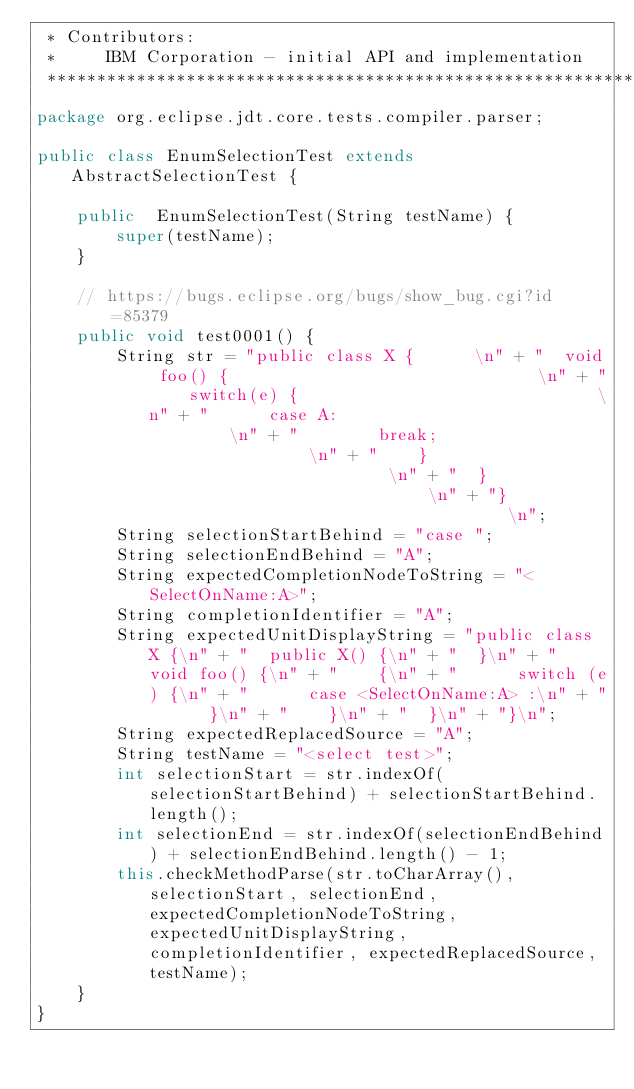<code> <loc_0><loc_0><loc_500><loc_500><_Java_> * Contributors:
 *     IBM Corporation - initial API and implementation
 *******************************************************************************/
package org.eclipse.jdt.core.tests.compiler.parser;

public class EnumSelectionTest extends AbstractSelectionTest {

    public  EnumSelectionTest(String testName) {
        super(testName);
    }

    // https://bugs.eclipse.org/bugs/show_bug.cgi?id=85379
    public void test0001() {
        String str = "public class X {		\n" + "  void foo() {								\n" + "    switch(e) {  							\n" + "      case A:								\n" + "        break;								\n" + "    }        								\n" + "  }        								\n" + "}											\n";
        String selectionStartBehind = "case ";
        String selectionEndBehind = "A";
        String expectedCompletionNodeToString = "<SelectOnName:A>";
        String completionIdentifier = "A";
        String expectedUnitDisplayString = "public class X {\n" + "  public X() {\n" + "  }\n" + "  void foo() {\n" + "    {\n" + "      switch (e) {\n" + "      case <SelectOnName:A> :\n" + "      }\n" + "    }\n" + "  }\n" + "}\n";
        String expectedReplacedSource = "A";
        String testName = "<select test>";
        int selectionStart = str.indexOf(selectionStartBehind) + selectionStartBehind.length();
        int selectionEnd = str.indexOf(selectionEndBehind) + selectionEndBehind.length() - 1;
        this.checkMethodParse(str.toCharArray(), selectionStart, selectionEnd, expectedCompletionNodeToString, expectedUnitDisplayString, completionIdentifier, expectedReplacedSource, testName);
    }
}
</code> 